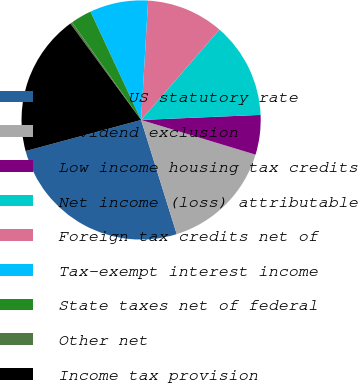Convert chart. <chart><loc_0><loc_0><loc_500><loc_500><pie_chart><fcel>Tax at US statutory rate<fcel>Dividend exclusion<fcel>Low income housing tax credits<fcel>Net income (loss) attributable<fcel>Foreign tax credits net of<fcel>Tax-exempt interest income<fcel>State taxes net of federal<fcel>Other net<fcel>Income tax provision<nl><fcel>25.63%<fcel>15.5%<fcel>5.36%<fcel>12.96%<fcel>10.43%<fcel>7.89%<fcel>2.83%<fcel>0.29%<fcel>19.11%<nl></chart> 